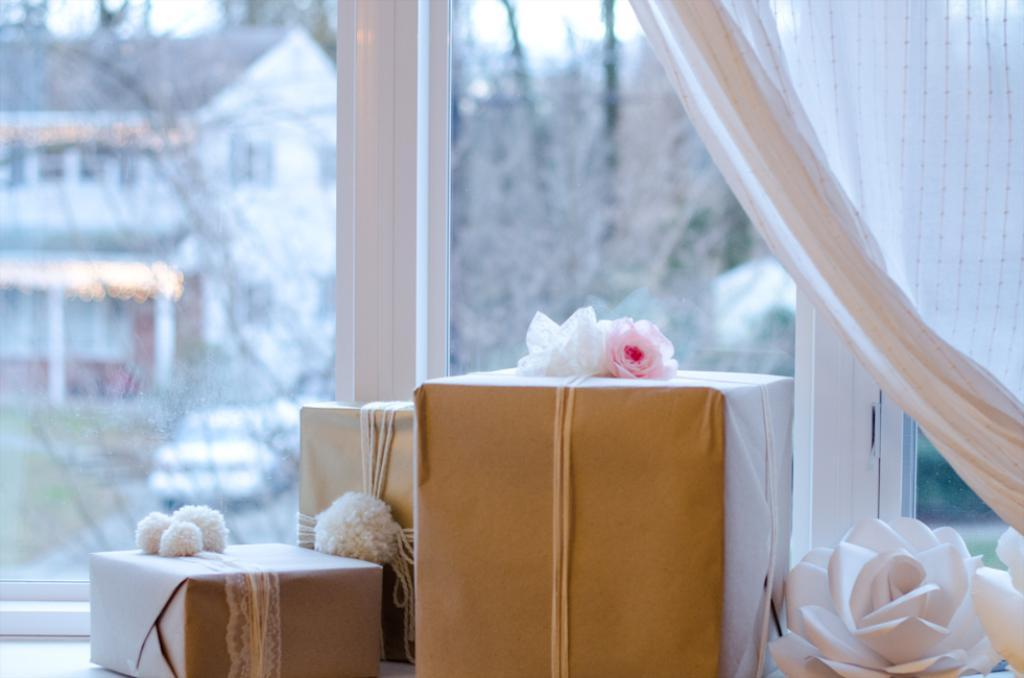What objects can be seen in the image? There are gifts and flowers in the image. Can you describe the setting of the image? There is a window in the background of the image. How is the window depicted in the image? The window appears to be blurred. How many girls are surprised by the gifts in the image? There are no girls present in the image, and the gifts are not associated with any surprise. 